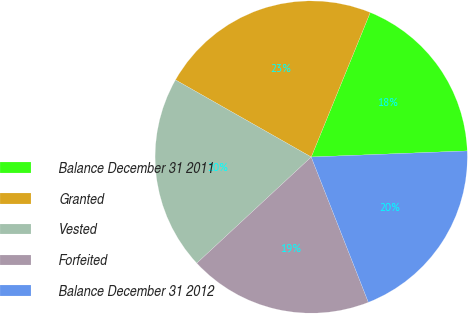Convert chart to OTSL. <chart><loc_0><loc_0><loc_500><loc_500><pie_chart><fcel>Balance December 31 2011<fcel>Granted<fcel>Vested<fcel>Forfeited<fcel>Balance December 31 2012<nl><fcel>18.21%<fcel>22.95%<fcel>20.13%<fcel>19.06%<fcel>19.66%<nl></chart> 